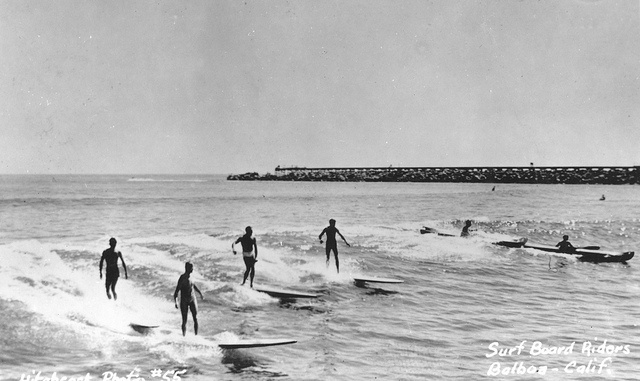Describe the objects in this image and their specific colors. I can see surfboard in lightgray, darkgray, black, and gray tones, people in lightgray, black, gray, and darkgray tones, people in lightgray, black, gray, and darkgray tones, people in lightgray, black, gray, and darkgray tones, and surfboard in lightgray, black, darkgray, and gray tones in this image. 